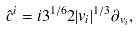Convert formula to latex. <formula><loc_0><loc_0><loc_500><loc_500>\hat { c } ^ { i } = i 3 ^ { 1 / 6 } 2 | v _ { i } | ^ { 1 / 3 } { \partial } _ { v _ { i } } ,</formula> 